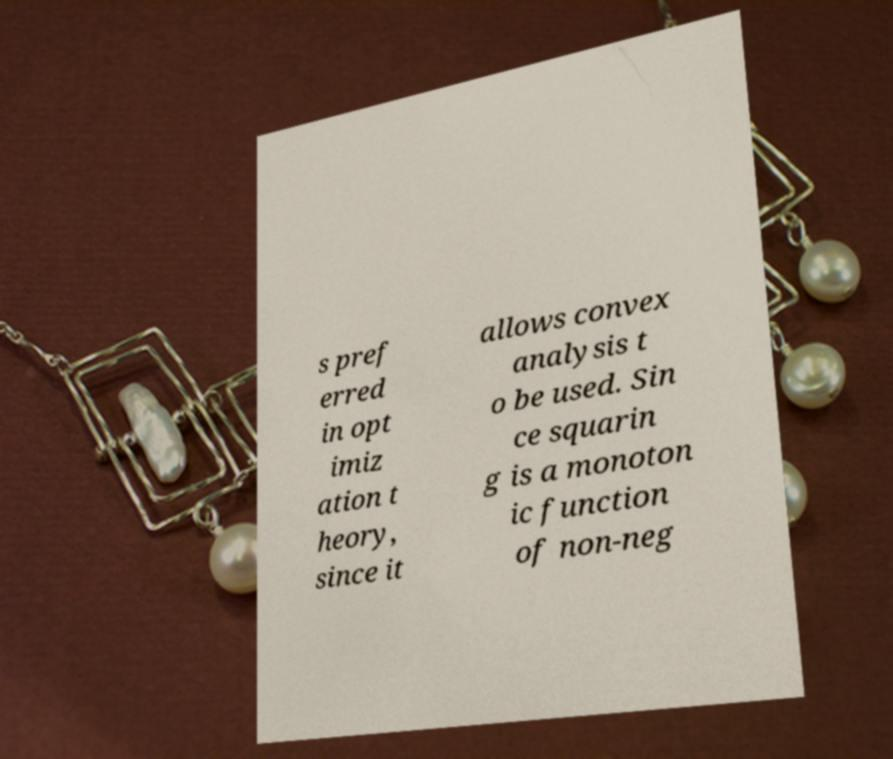I need the written content from this picture converted into text. Can you do that? s pref erred in opt imiz ation t heory, since it allows convex analysis t o be used. Sin ce squarin g is a monoton ic function of non-neg 